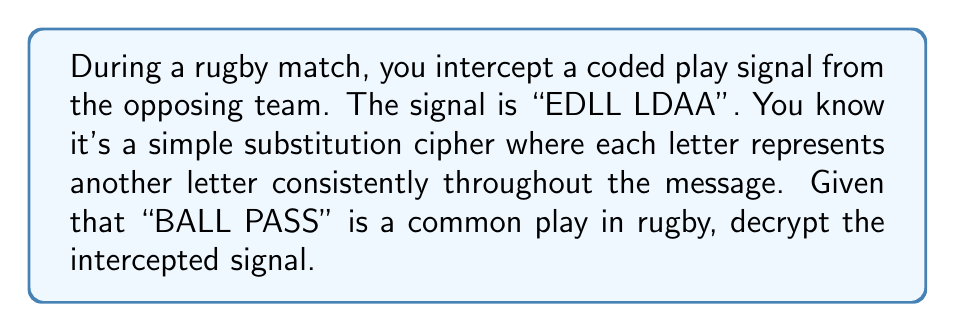Could you help me with this problem? To decrypt this substitution cipher, we'll follow these steps:

1) First, let's align the intercepted signal with the suspected original message:

   EDLL LDAA
   BALL PASS

2) We can now create a substitution key:
   E → B
   D → A
   L → L
   A → S

3) Let's verify if this key is consistent:
   - The first L in EDLL corresponds to L in BALL
   - The second L in EDLL corresponds to L in BALL
   - The L in LDAA corresponds to P in PASS

4) We notice an inconsistency with L. It can't represent both L and P.

5) Let's adjust our assumption. Instead of "BALL PASS", let's try "PASS BALL":

   EDLL LDAA
   PASS BALL

6) Now we can create a consistent substitution key:
   E → P
   D → A
   L → S
   A → L

7) This key works consistently for all letters in the message.

Therefore, the decrypted message is "PASS BALL".
Answer: PASS BALL 